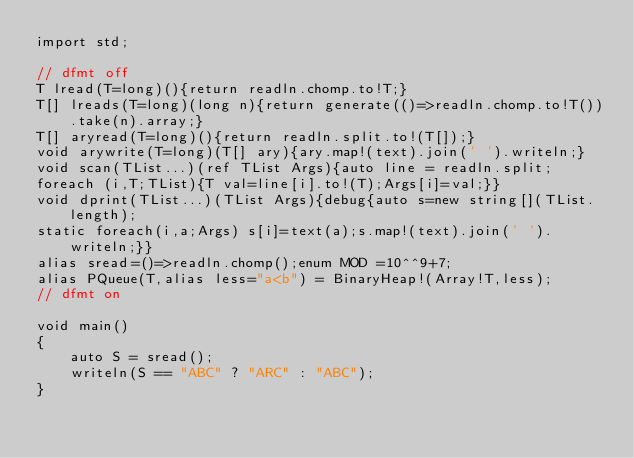<code> <loc_0><loc_0><loc_500><loc_500><_D_>import std;

// dfmt off
T lread(T=long)(){return readln.chomp.to!T;}
T[] lreads(T=long)(long n){return generate(()=>readln.chomp.to!T()).take(n).array;}
T[] aryread(T=long)(){return readln.split.to!(T[]);}
void arywrite(T=long)(T[] ary){ary.map!(text).join(' ').writeln;}
void scan(TList...)(ref TList Args){auto line = readln.split;
foreach (i,T;TList){T val=line[i].to!(T);Args[i]=val;}}
void dprint(TList...)(TList Args){debug{auto s=new string[](TList.length);
static foreach(i,a;Args) s[i]=text(a);s.map!(text).join(' ').writeln;}}
alias sread=()=>readln.chomp();enum MOD =10^^9+7;
alias PQueue(T,alias less="a<b") = BinaryHeap!(Array!T,less);
// dfmt on

void main()
{
    auto S = sread();
    writeln(S == "ABC" ? "ARC" : "ABC");
}
</code> 